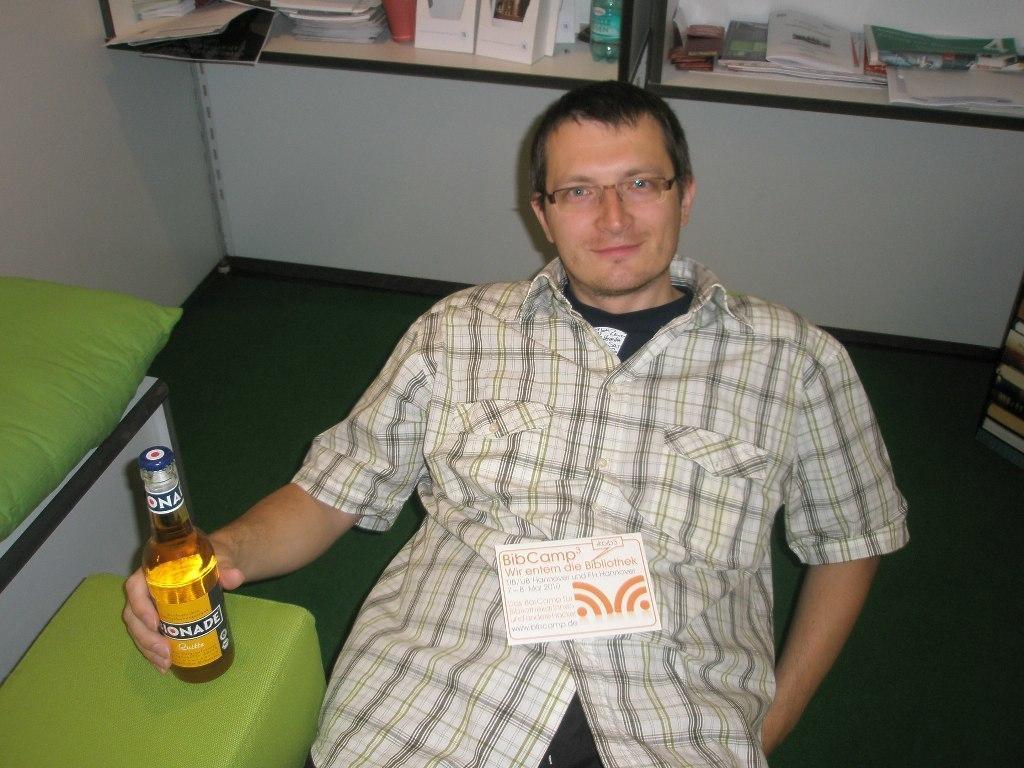In one or two sentences, can you explain what this image depicts? in the middle there is a man, he is catching a bottle ,he is wearing a shirt ,he is smiling. In the background we can see shelf's there are many items on that. 